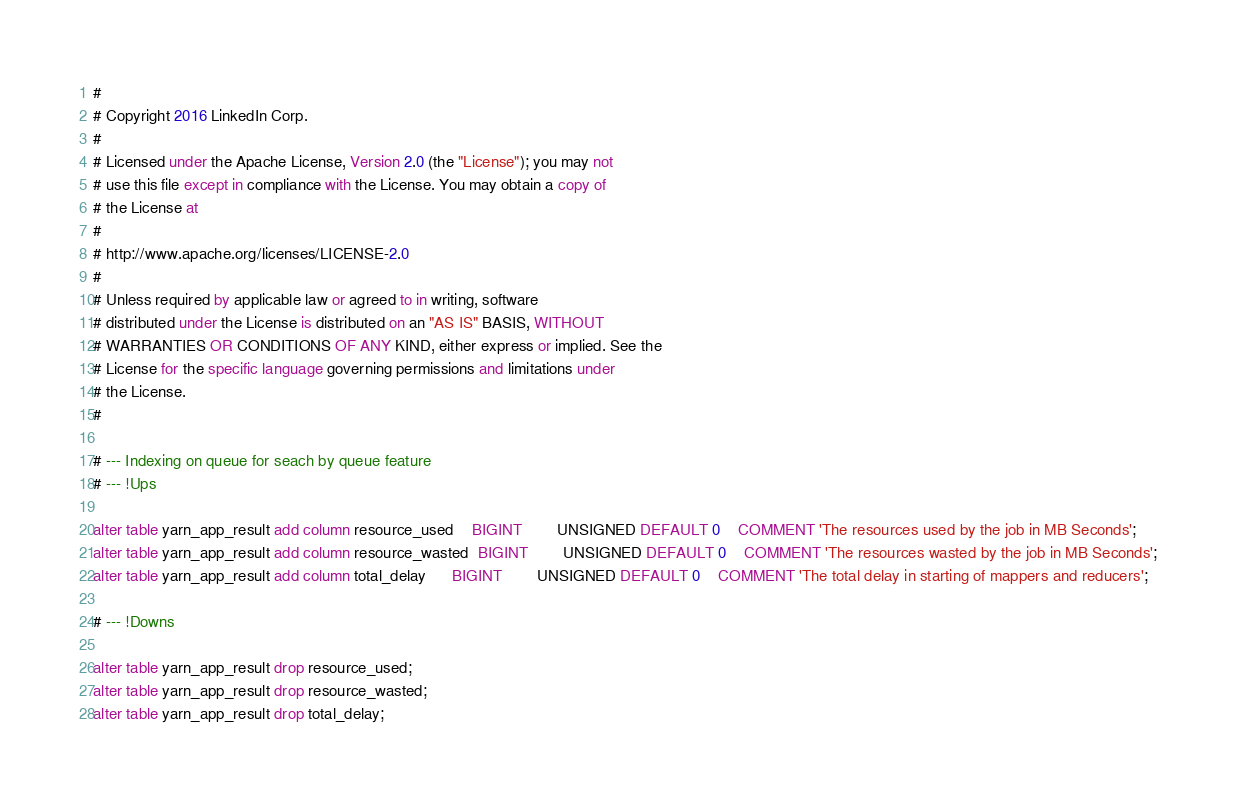<code> <loc_0><loc_0><loc_500><loc_500><_SQL_>#
# Copyright 2016 LinkedIn Corp.
#
# Licensed under the Apache License, Version 2.0 (the "License"); you may not
# use this file except in compliance with the License. You may obtain a copy of
# the License at
#
# http://www.apache.org/licenses/LICENSE-2.0
#
# Unless required by applicable law or agreed to in writing, software
# distributed under the License is distributed on an "AS IS" BASIS, WITHOUT
# WARRANTIES OR CONDITIONS OF ANY KIND, either express or implied. See the
# License for the specific language governing permissions and limitations under
# the License.
#

# --- Indexing on queue for seach by queue feature
# --- !Ups

alter table yarn_app_result add column resource_used    BIGINT        UNSIGNED DEFAULT 0    COMMENT 'The resources used by the job in MB Seconds';
alter table yarn_app_result add column resource_wasted  BIGINT        UNSIGNED DEFAULT 0    COMMENT 'The resources wasted by the job in MB Seconds';
alter table yarn_app_result add column total_delay      BIGINT        UNSIGNED DEFAULT 0    COMMENT 'The total delay in starting of mappers and reducers';

# --- !Downs

alter table yarn_app_result drop resource_used;
alter table yarn_app_result drop resource_wasted;
alter table yarn_app_result drop total_delay;




</code> 